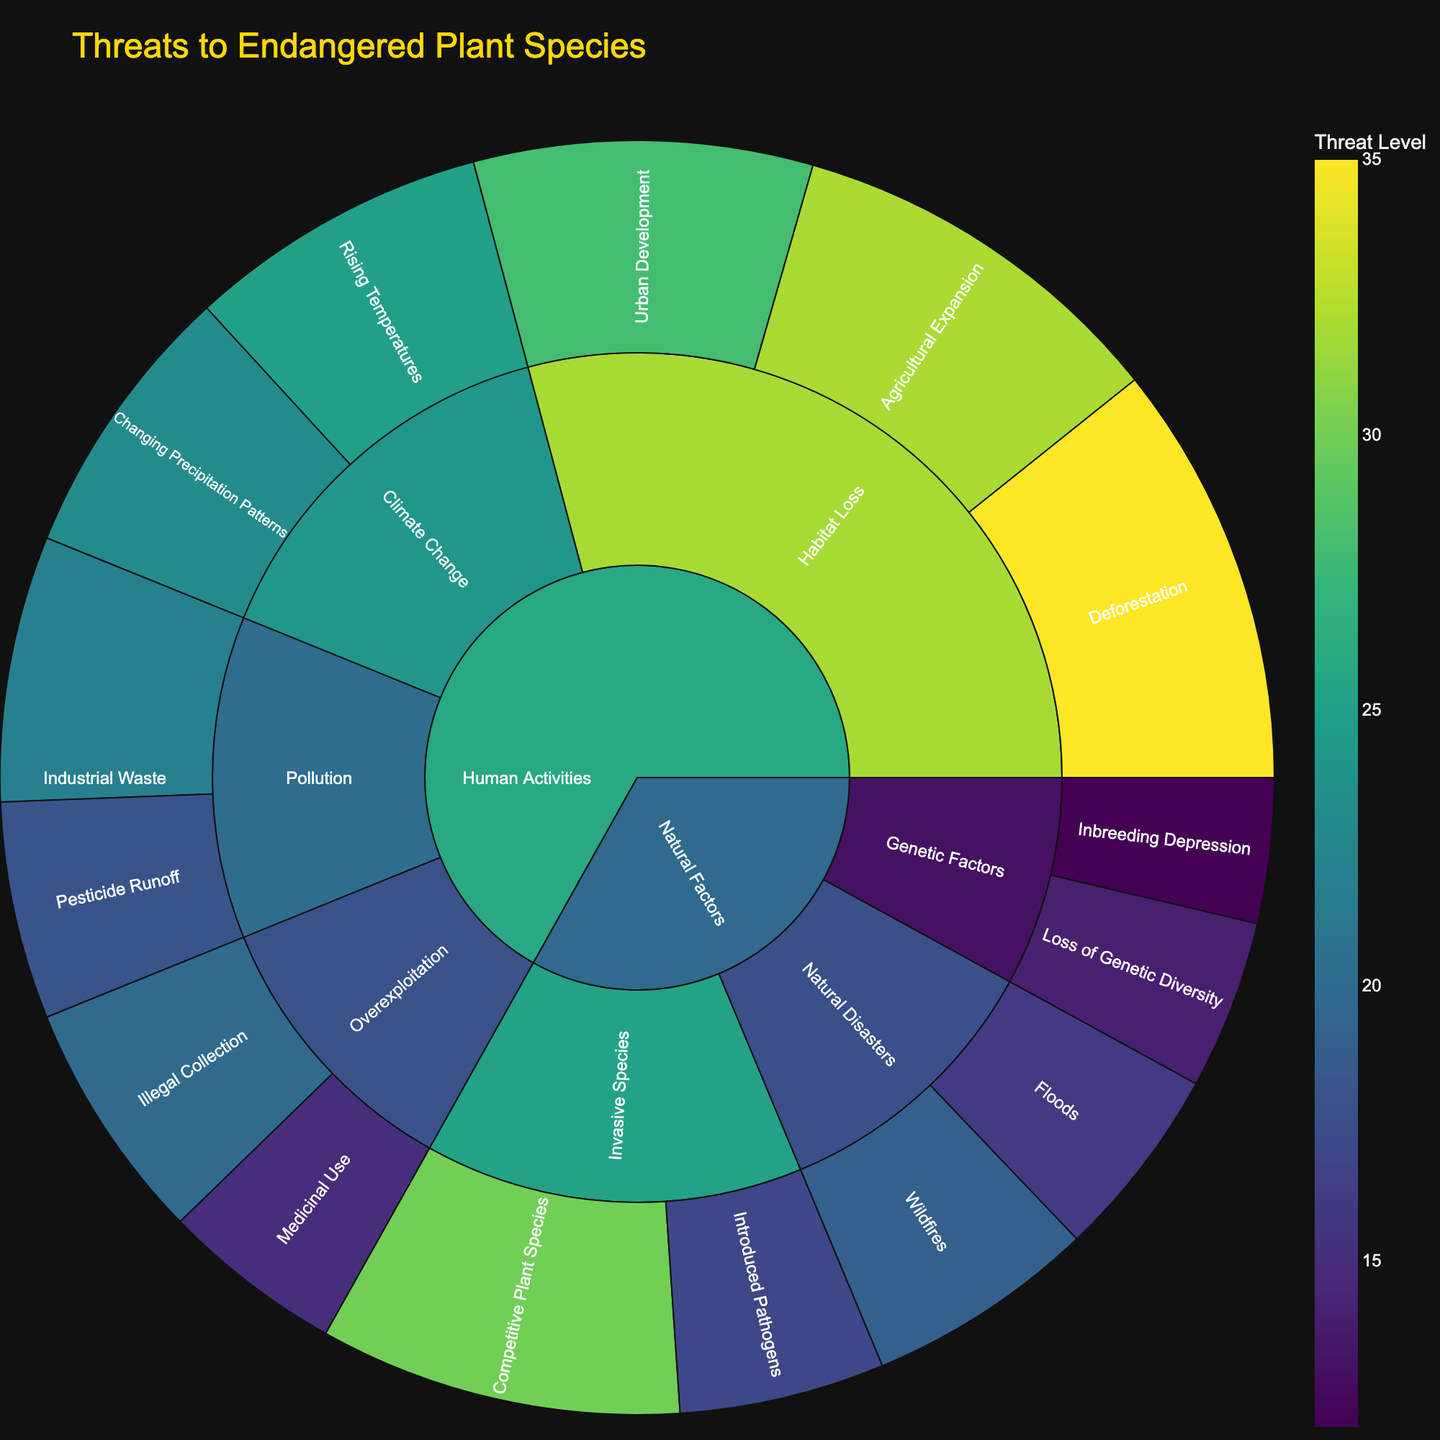What categories of threats are included in the figure? The figure displays two main categories of threats: 'Human Activities' and 'Natural Factors'.
Answer: 'Human Activities' and 'Natural Factors' What is the title of the figure? The title is located at the top of the figure.
Answer: 'Threats to Endangered Plant Species' Which threat under "Natural Disasters" has the highest value? Under the 'Natural Disasters' subcategory, compare the values of 'Wildfires' and 'Floods'. 'Wildfires' has a value of 19, which is higher than 'Floods' with 16.
Answer: 'Wildfires' Which threat in "Human Activities" has the lowest value? Compare values of all threats under 'Human Activities' - 'Illegal Collection' has the lowest value of 20.
Answer: 'Medicinal Use' What is the total value of threats under the 'Habitat Loss' subcategory? Sum the values of all threats under 'Habitat Loss' (35 for Deforestation, 28 for Urban Development, 32 for Agricultural Expansion). 35 + 28 + 32 = 95
Answer: 95 Is 'Changing Precipitation Patterns' or 'Rising Temperatures' a larger threat under 'Climate Change'? Compare the values under 'Climate Change' subcategory, 'Rising Temperatures' is 25, and 'Changing Precipitation Patterns' is 23. 'Rising Temperatures' is larger.
Answer: 'Rising Temperatures' What is the combined threat level of all 'Invasive Species'? Sum the values of 'Competitive Plant Species' and 'Introduced Pathogens' under 'Invasive Species' - 30 + 17 = 47.
Answer: 47 Which has a higher value: deforestation or pesticide runoff? Compare the values directly: 'Deforestation' is 35, and 'Pesticide Runoff' is 18. 'Deforestation' is higher.
Answer: 'Deforestation' What is the average value of all threats under "Natural Factors"? Sum all values under 'Natural Factors' (30, 17, 12, 14, 19, 16) and divide by their count. (30 + 17 + 12 + 14 + 19 + 16) / 6 = 108 / 6 = 18
Answer: 18 Which subcategory within 'Human Activities' has the highest cumulative value? Sum values within each subcategory: Habitat Loss (35+28+32=95), Overexploitation (20+15=35), Pollution (18+22=40), Climate Change (25+23=48). The highest is 'Habitat Loss' with 95.
Answer: 'Habitat Loss' 